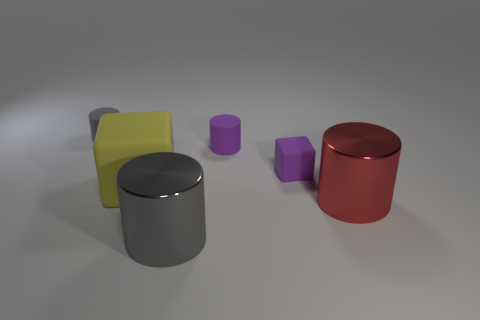Subtract all gray shiny cylinders. How many cylinders are left? 3 Subtract all yellow spheres. How many gray cylinders are left? 2 Subtract 3 cylinders. How many cylinders are left? 1 Add 2 small purple rubber balls. How many objects exist? 8 Subtract all gray cylinders. How many cylinders are left? 2 Subtract all cylinders. How many objects are left? 2 Subtract all red cubes. Subtract all brown cylinders. How many cubes are left? 2 Subtract all gray rubber cylinders. Subtract all gray shiny things. How many objects are left? 4 Add 2 big cylinders. How many big cylinders are left? 4 Add 2 big yellow matte cubes. How many big yellow matte cubes exist? 3 